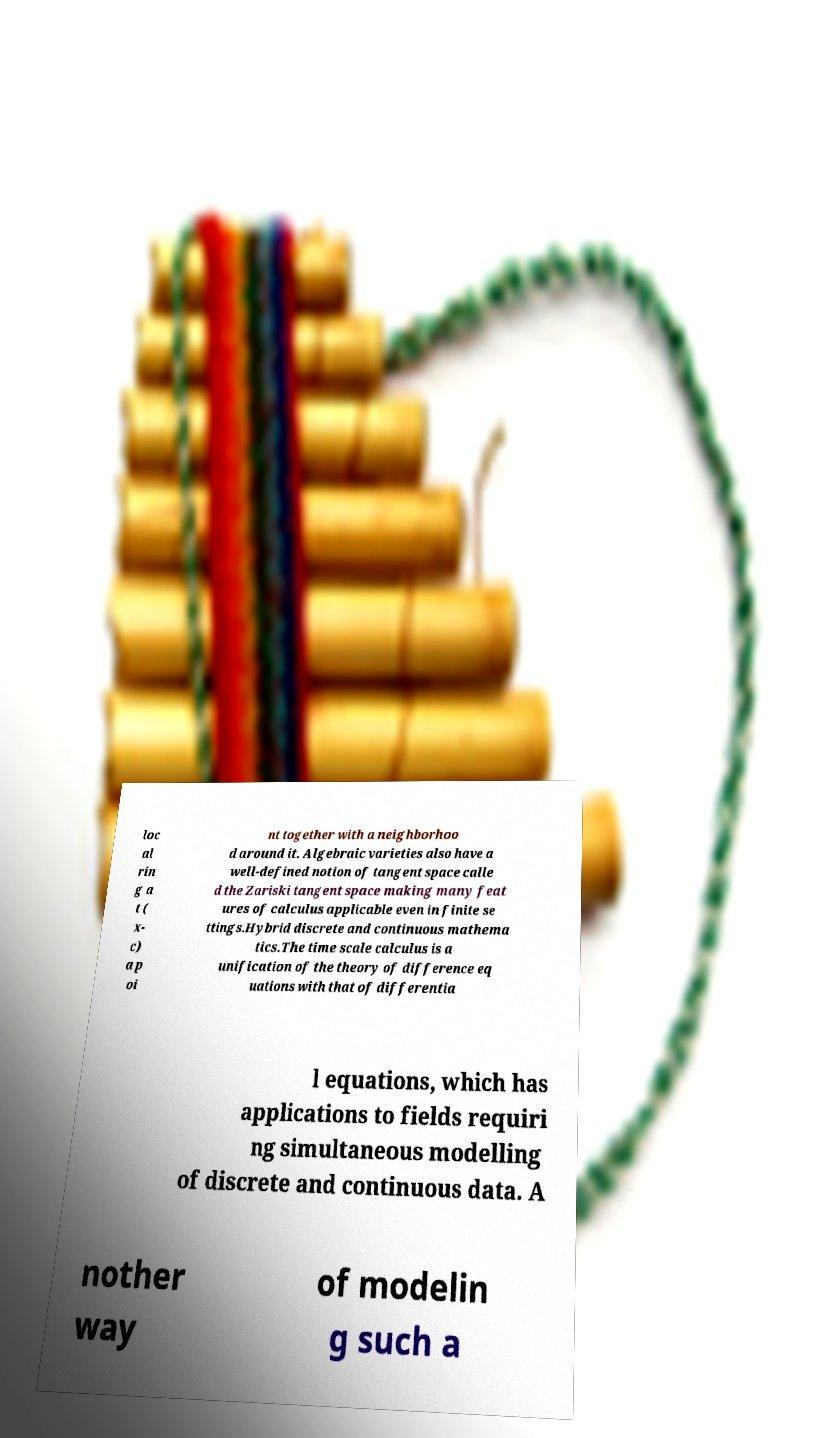I need the written content from this picture converted into text. Can you do that? loc al rin g a t ( x- c) a p oi nt together with a neighborhoo d around it. Algebraic varieties also have a well-defined notion of tangent space calle d the Zariski tangent space making many feat ures of calculus applicable even in finite se ttings.Hybrid discrete and continuous mathema tics.The time scale calculus is a unification of the theory of difference eq uations with that of differentia l equations, which has applications to fields requiri ng simultaneous modelling of discrete and continuous data. A nother way of modelin g such a 